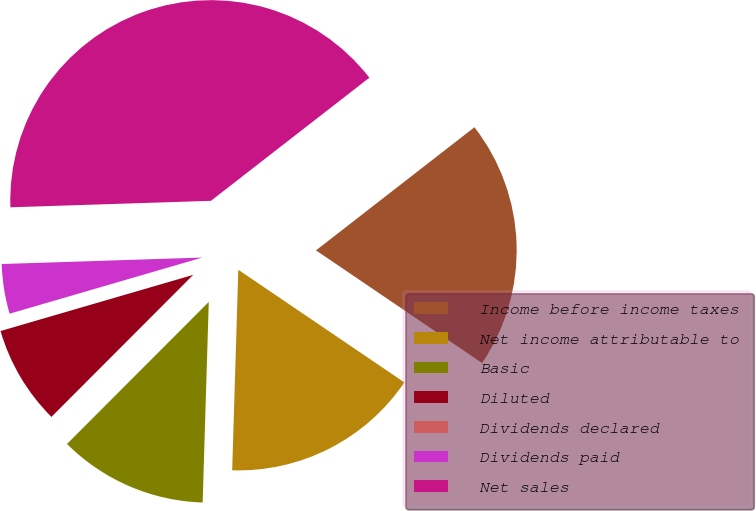Convert chart. <chart><loc_0><loc_0><loc_500><loc_500><pie_chart><fcel>Income before income taxes<fcel>Net income attributable to<fcel>Basic<fcel>Diluted<fcel>Dividends declared<fcel>Dividends paid<fcel>Net sales<nl><fcel>20.0%<fcel>16.0%<fcel>12.0%<fcel>8.0%<fcel>0.0%<fcel>4.0%<fcel>40.0%<nl></chart> 